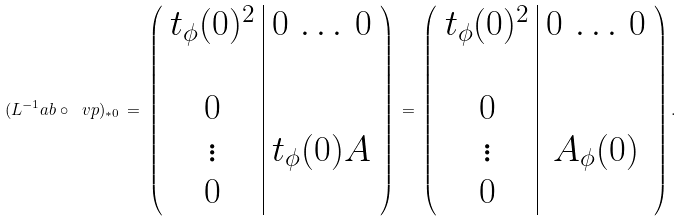<formula> <loc_0><loc_0><loc_500><loc_500>( L ^ { - 1 } _ { \ } a b \circ \ v p ) _ { \ast 0 } \, = \, \left ( \begin{array} { c | c } t _ { \phi } ( 0 ) ^ { 2 } & 0 \, \dots \, 0 \\ \\ 0 & \\ \vdots & t _ { \phi } ( 0 ) A \\ 0 & \end{array} \right ) \, = \, \left ( \begin{array} { c | c } t _ { \phi } ( 0 ) ^ { 2 } & 0 \, \dots \, 0 \\ \\ 0 & \\ \vdots & A _ { \phi } ( 0 ) \\ 0 & \end{array} \right ) .</formula> 